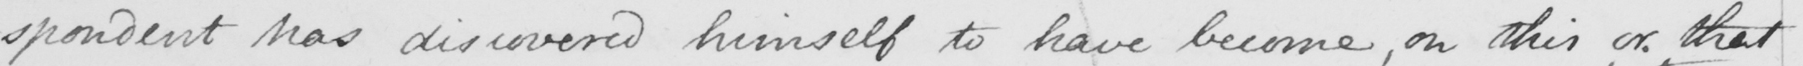Please transcribe the handwritten text in this image. -spondent has discovered himself to have become , on this or that 